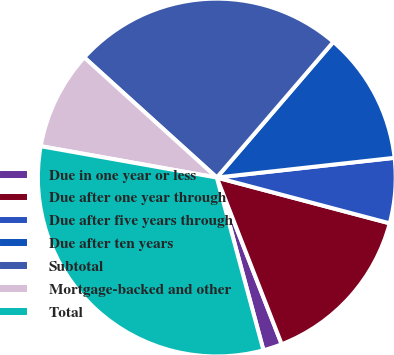Convert chart. <chart><loc_0><loc_0><loc_500><loc_500><pie_chart><fcel>Due in one year or less<fcel>Due after one year through<fcel>Due after five years through<fcel>Due after ten years<fcel>Subtotal<fcel>Mortgage-backed and other<fcel>Total<nl><fcel>1.71%<fcel>14.97%<fcel>5.88%<fcel>11.94%<fcel>24.58%<fcel>8.91%<fcel>32.0%<nl></chart> 